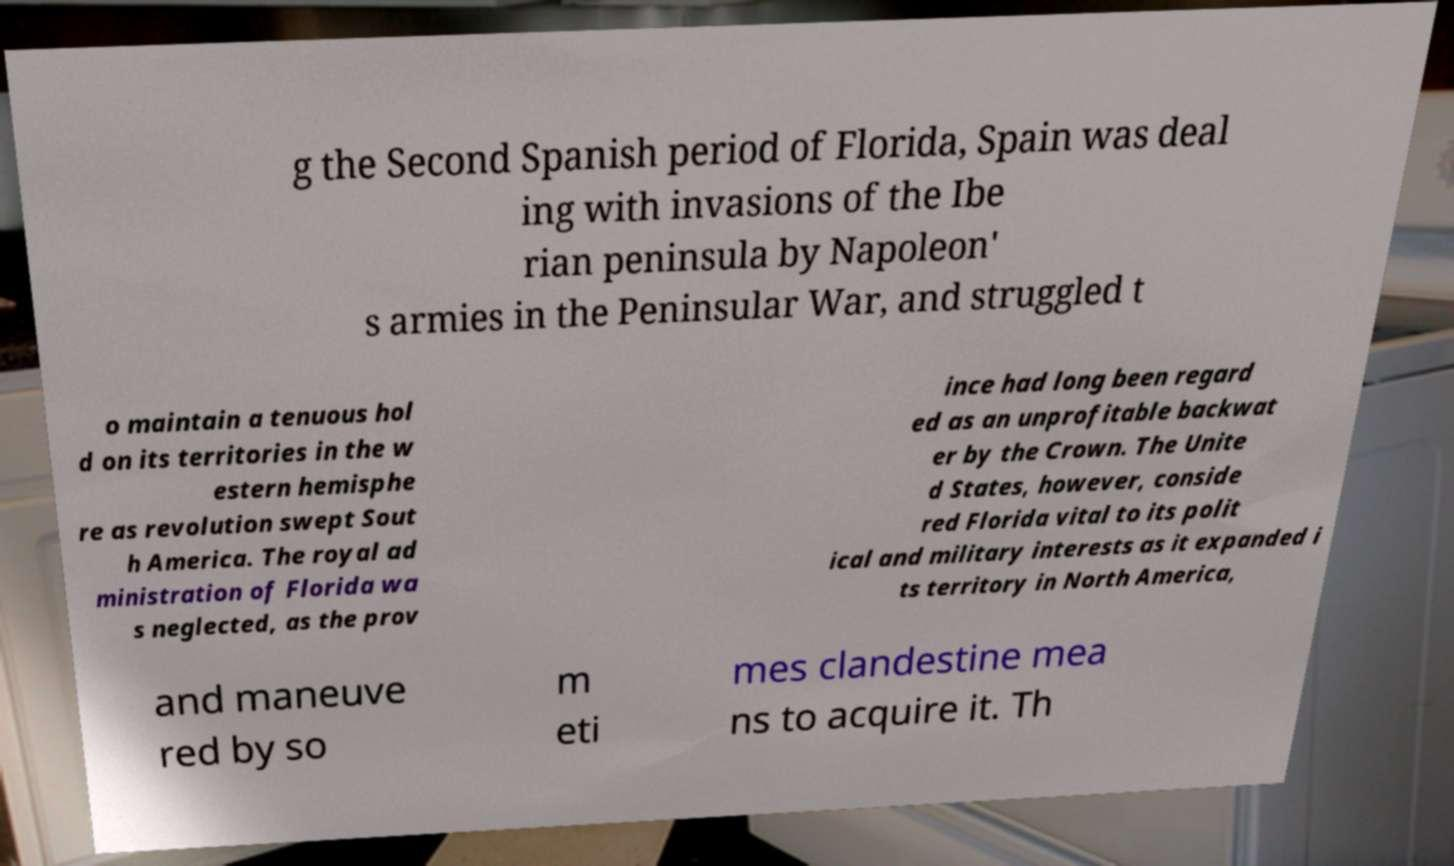There's text embedded in this image that I need extracted. Can you transcribe it verbatim? g the Second Spanish period of Florida, Spain was deal ing with invasions of the Ibe rian peninsula by Napoleon' s armies in the Peninsular War, and struggled t o maintain a tenuous hol d on its territories in the w estern hemisphe re as revolution swept Sout h America. The royal ad ministration of Florida wa s neglected, as the prov ince had long been regard ed as an unprofitable backwat er by the Crown. The Unite d States, however, conside red Florida vital to its polit ical and military interests as it expanded i ts territory in North America, and maneuve red by so m eti mes clandestine mea ns to acquire it. Th 